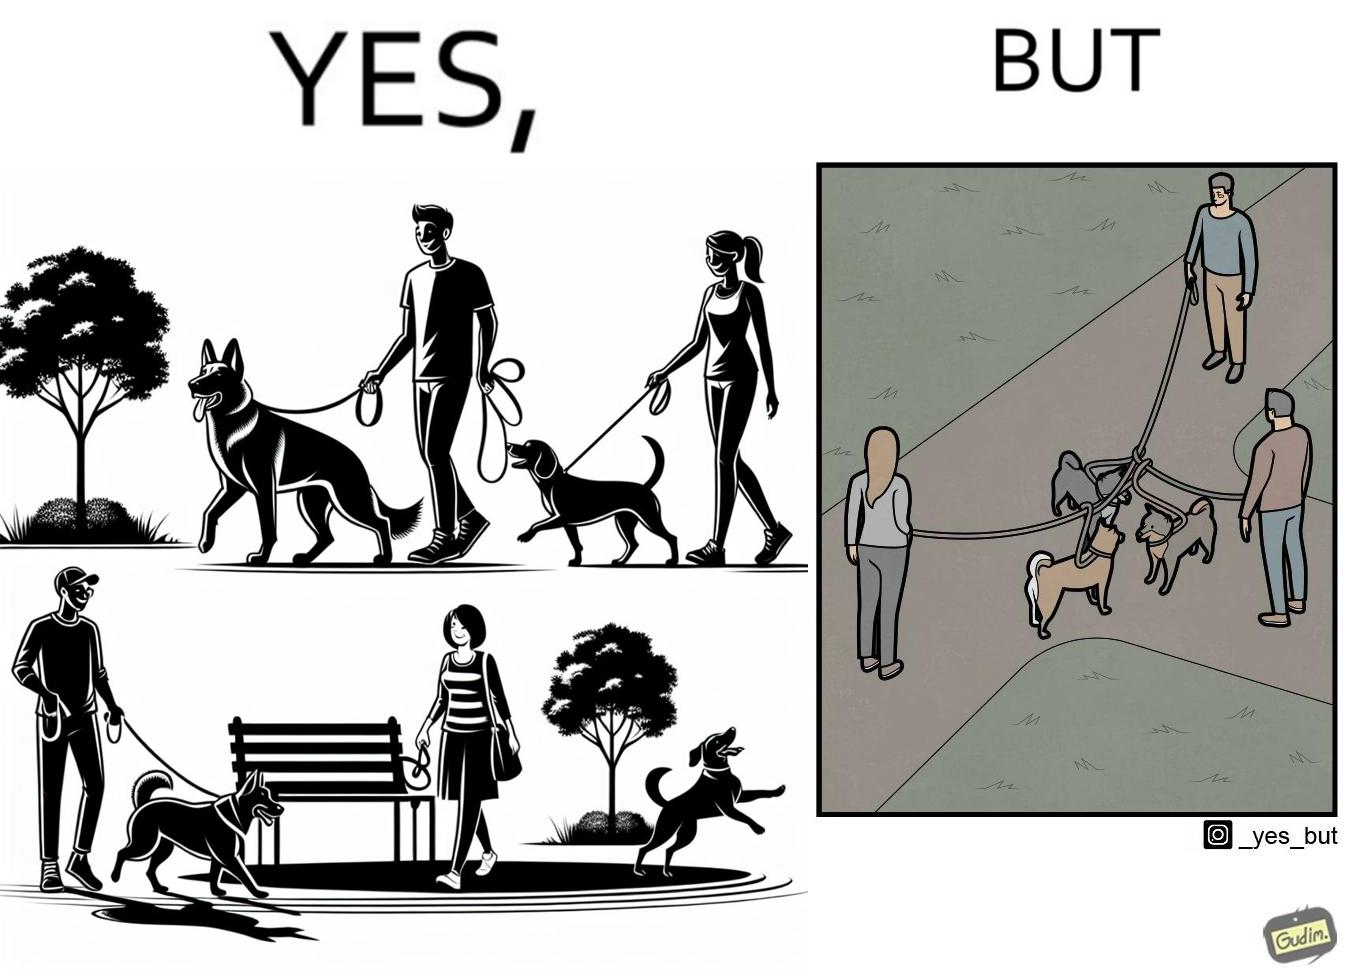Describe the satirical element in this image. The dog owners take their dogs for some walk in parks but their dogs mingle together with other dogs however their leashes get entangled during this which is quite inconvenient for the dog owners 